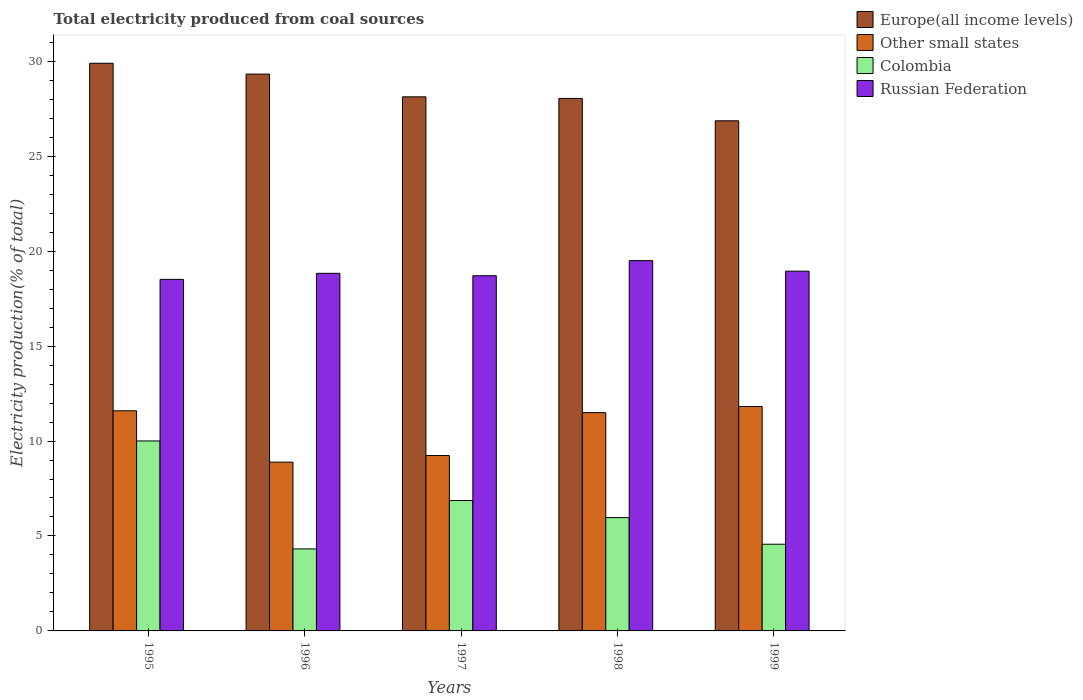Are the number of bars per tick equal to the number of legend labels?
Provide a succinct answer. Yes. Are the number of bars on each tick of the X-axis equal?
Your answer should be very brief. Yes. In how many cases, is the number of bars for a given year not equal to the number of legend labels?
Keep it short and to the point. 0. What is the total electricity produced in Europe(all income levels) in 1995?
Offer a very short reply. 29.89. Across all years, what is the maximum total electricity produced in Other small states?
Ensure brevity in your answer.  11.82. Across all years, what is the minimum total electricity produced in Colombia?
Offer a very short reply. 4.32. In which year was the total electricity produced in Russian Federation maximum?
Keep it short and to the point. 1998. What is the total total electricity produced in Colombia in the graph?
Your response must be concise. 31.72. What is the difference between the total electricity produced in Other small states in 1996 and that in 1998?
Your answer should be very brief. -2.61. What is the difference between the total electricity produced in Other small states in 1997 and the total electricity produced in Russian Federation in 1995?
Make the answer very short. -9.28. What is the average total electricity produced in Europe(all income levels) per year?
Keep it short and to the point. 28.45. In the year 1996, what is the difference between the total electricity produced in Colombia and total electricity produced in Russian Federation?
Give a very brief answer. -14.51. What is the ratio of the total electricity produced in Colombia in 1998 to that in 1999?
Your answer should be very brief. 1.31. Is the difference between the total electricity produced in Colombia in 1996 and 1999 greater than the difference between the total electricity produced in Russian Federation in 1996 and 1999?
Make the answer very short. No. What is the difference between the highest and the second highest total electricity produced in Colombia?
Ensure brevity in your answer.  3.14. What is the difference between the highest and the lowest total electricity produced in Other small states?
Your response must be concise. 2.93. Is the sum of the total electricity produced in Colombia in 1996 and 1998 greater than the maximum total electricity produced in Europe(all income levels) across all years?
Offer a terse response. No. What does the 1st bar from the right in 1996 represents?
Your response must be concise. Russian Federation. Is it the case that in every year, the sum of the total electricity produced in Europe(all income levels) and total electricity produced in Russian Federation is greater than the total electricity produced in Other small states?
Offer a terse response. Yes. How many bars are there?
Offer a very short reply. 20. How many years are there in the graph?
Offer a very short reply. 5. Are the values on the major ticks of Y-axis written in scientific E-notation?
Provide a short and direct response. No. Does the graph contain any zero values?
Ensure brevity in your answer.  No. How are the legend labels stacked?
Ensure brevity in your answer.  Vertical. What is the title of the graph?
Ensure brevity in your answer.  Total electricity produced from coal sources. Does "Bahrain" appear as one of the legend labels in the graph?
Give a very brief answer. No. What is the Electricity production(% of total) of Europe(all income levels) in 1995?
Provide a succinct answer. 29.89. What is the Electricity production(% of total) in Other small states in 1995?
Ensure brevity in your answer.  11.59. What is the Electricity production(% of total) in Colombia in 1995?
Keep it short and to the point. 10. What is the Electricity production(% of total) of Russian Federation in 1995?
Your response must be concise. 18.51. What is the Electricity production(% of total) in Europe(all income levels) in 1996?
Ensure brevity in your answer.  29.32. What is the Electricity production(% of total) of Other small states in 1996?
Give a very brief answer. 8.89. What is the Electricity production(% of total) of Colombia in 1996?
Your response must be concise. 4.32. What is the Electricity production(% of total) of Russian Federation in 1996?
Your answer should be very brief. 18.83. What is the Electricity production(% of total) in Europe(all income levels) in 1997?
Keep it short and to the point. 28.13. What is the Electricity production(% of total) in Other small states in 1997?
Ensure brevity in your answer.  9.24. What is the Electricity production(% of total) in Colombia in 1997?
Provide a short and direct response. 6.87. What is the Electricity production(% of total) in Russian Federation in 1997?
Your response must be concise. 18.7. What is the Electricity production(% of total) of Europe(all income levels) in 1998?
Keep it short and to the point. 28.04. What is the Electricity production(% of total) in Other small states in 1998?
Offer a terse response. 11.5. What is the Electricity production(% of total) in Colombia in 1998?
Make the answer very short. 5.97. What is the Electricity production(% of total) of Russian Federation in 1998?
Keep it short and to the point. 19.5. What is the Electricity production(% of total) in Europe(all income levels) in 1999?
Make the answer very short. 26.86. What is the Electricity production(% of total) of Other small states in 1999?
Offer a terse response. 11.82. What is the Electricity production(% of total) in Colombia in 1999?
Offer a very short reply. 4.57. What is the Electricity production(% of total) of Russian Federation in 1999?
Your answer should be compact. 18.94. Across all years, what is the maximum Electricity production(% of total) in Europe(all income levels)?
Ensure brevity in your answer.  29.89. Across all years, what is the maximum Electricity production(% of total) of Other small states?
Offer a terse response. 11.82. Across all years, what is the maximum Electricity production(% of total) in Colombia?
Make the answer very short. 10. Across all years, what is the maximum Electricity production(% of total) in Russian Federation?
Your answer should be very brief. 19.5. Across all years, what is the minimum Electricity production(% of total) of Europe(all income levels)?
Your response must be concise. 26.86. Across all years, what is the minimum Electricity production(% of total) in Other small states?
Provide a short and direct response. 8.89. Across all years, what is the minimum Electricity production(% of total) of Colombia?
Give a very brief answer. 4.32. Across all years, what is the minimum Electricity production(% of total) in Russian Federation?
Give a very brief answer. 18.51. What is the total Electricity production(% of total) of Europe(all income levels) in the graph?
Keep it short and to the point. 142.24. What is the total Electricity production(% of total) of Other small states in the graph?
Your answer should be very brief. 53.03. What is the total Electricity production(% of total) of Colombia in the graph?
Provide a short and direct response. 31.72. What is the total Electricity production(% of total) of Russian Federation in the graph?
Offer a very short reply. 94.49. What is the difference between the Electricity production(% of total) in Europe(all income levels) in 1995 and that in 1996?
Offer a very short reply. 0.57. What is the difference between the Electricity production(% of total) of Other small states in 1995 and that in 1996?
Your answer should be very brief. 2.7. What is the difference between the Electricity production(% of total) in Colombia in 1995 and that in 1996?
Your answer should be very brief. 5.68. What is the difference between the Electricity production(% of total) in Russian Federation in 1995 and that in 1996?
Provide a short and direct response. -0.32. What is the difference between the Electricity production(% of total) of Europe(all income levels) in 1995 and that in 1997?
Offer a terse response. 1.77. What is the difference between the Electricity production(% of total) of Other small states in 1995 and that in 1997?
Offer a very short reply. 2.36. What is the difference between the Electricity production(% of total) of Colombia in 1995 and that in 1997?
Your answer should be very brief. 3.14. What is the difference between the Electricity production(% of total) in Russian Federation in 1995 and that in 1997?
Provide a succinct answer. -0.19. What is the difference between the Electricity production(% of total) in Europe(all income levels) in 1995 and that in 1998?
Your answer should be very brief. 1.85. What is the difference between the Electricity production(% of total) of Other small states in 1995 and that in 1998?
Offer a very short reply. 0.1. What is the difference between the Electricity production(% of total) in Colombia in 1995 and that in 1998?
Provide a short and direct response. 4.04. What is the difference between the Electricity production(% of total) of Russian Federation in 1995 and that in 1998?
Offer a very short reply. -0.99. What is the difference between the Electricity production(% of total) of Europe(all income levels) in 1995 and that in 1999?
Offer a terse response. 3.03. What is the difference between the Electricity production(% of total) of Other small states in 1995 and that in 1999?
Your answer should be compact. -0.23. What is the difference between the Electricity production(% of total) of Colombia in 1995 and that in 1999?
Your answer should be very brief. 5.44. What is the difference between the Electricity production(% of total) in Russian Federation in 1995 and that in 1999?
Your answer should be compact. -0.43. What is the difference between the Electricity production(% of total) of Europe(all income levels) in 1996 and that in 1997?
Give a very brief answer. 1.2. What is the difference between the Electricity production(% of total) of Other small states in 1996 and that in 1997?
Offer a very short reply. -0.35. What is the difference between the Electricity production(% of total) of Colombia in 1996 and that in 1997?
Your response must be concise. -2.55. What is the difference between the Electricity production(% of total) of Russian Federation in 1996 and that in 1997?
Your answer should be very brief. 0.13. What is the difference between the Electricity production(% of total) in Europe(all income levels) in 1996 and that in 1998?
Offer a terse response. 1.28. What is the difference between the Electricity production(% of total) of Other small states in 1996 and that in 1998?
Your response must be concise. -2.61. What is the difference between the Electricity production(% of total) of Colombia in 1996 and that in 1998?
Give a very brief answer. -1.65. What is the difference between the Electricity production(% of total) of Russian Federation in 1996 and that in 1998?
Offer a terse response. -0.67. What is the difference between the Electricity production(% of total) in Europe(all income levels) in 1996 and that in 1999?
Your answer should be compact. 2.46. What is the difference between the Electricity production(% of total) of Other small states in 1996 and that in 1999?
Keep it short and to the point. -2.93. What is the difference between the Electricity production(% of total) in Colombia in 1996 and that in 1999?
Provide a short and direct response. -0.25. What is the difference between the Electricity production(% of total) of Russian Federation in 1996 and that in 1999?
Ensure brevity in your answer.  -0.11. What is the difference between the Electricity production(% of total) of Europe(all income levels) in 1997 and that in 1998?
Make the answer very short. 0.08. What is the difference between the Electricity production(% of total) of Other small states in 1997 and that in 1998?
Offer a terse response. -2.26. What is the difference between the Electricity production(% of total) of Colombia in 1997 and that in 1998?
Provide a short and direct response. 0.9. What is the difference between the Electricity production(% of total) in Russian Federation in 1997 and that in 1998?
Provide a succinct answer. -0.79. What is the difference between the Electricity production(% of total) of Europe(all income levels) in 1997 and that in 1999?
Make the answer very short. 1.26. What is the difference between the Electricity production(% of total) of Other small states in 1997 and that in 1999?
Keep it short and to the point. -2.58. What is the difference between the Electricity production(% of total) in Colombia in 1997 and that in 1999?
Offer a terse response. 2.3. What is the difference between the Electricity production(% of total) of Russian Federation in 1997 and that in 1999?
Keep it short and to the point. -0.24. What is the difference between the Electricity production(% of total) in Europe(all income levels) in 1998 and that in 1999?
Your response must be concise. 1.18. What is the difference between the Electricity production(% of total) in Other small states in 1998 and that in 1999?
Offer a terse response. -0.32. What is the difference between the Electricity production(% of total) in Colombia in 1998 and that in 1999?
Your answer should be very brief. 1.4. What is the difference between the Electricity production(% of total) in Russian Federation in 1998 and that in 1999?
Give a very brief answer. 0.55. What is the difference between the Electricity production(% of total) in Europe(all income levels) in 1995 and the Electricity production(% of total) in Other small states in 1996?
Provide a succinct answer. 21.01. What is the difference between the Electricity production(% of total) in Europe(all income levels) in 1995 and the Electricity production(% of total) in Colombia in 1996?
Ensure brevity in your answer.  25.57. What is the difference between the Electricity production(% of total) in Europe(all income levels) in 1995 and the Electricity production(% of total) in Russian Federation in 1996?
Your response must be concise. 11.06. What is the difference between the Electricity production(% of total) in Other small states in 1995 and the Electricity production(% of total) in Colombia in 1996?
Offer a very short reply. 7.27. What is the difference between the Electricity production(% of total) of Other small states in 1995 and the Electricity production(% of total) of Russian Federation in 1996?
Provide a succinct answer. -7.24. What is the difference between the Electricity production(% of total) in Colombia in 1995 and the Electricity production(% of total) in Russian Federation in 1996?
Ensure brevity in your answer.  -8.83. What is the difference between the Electricity production(% of total) in Europe(all income levels) in 1995 and the Electricity production(% of total) in Other small states in 1997?
Ensure brevity in your answer.  20.66. What is the difference between the Electricity production(% of total) of Europe(all income levels) in 1995 and the Electricity production(% of total) of Colombia in 1997?
Your answer should be very brief. 23.03. What is the difference between the Electricity production(% of total) in Europe(all income levels) in 1995 and the Electricity production(% of total) in Russian Federation in 1997?
Offer a terse response. 11.19. What is the difference between the Electricity production(% of total) of Other small states in 1995 and the Electricity production(% of total) of Colombia in 1997?
Your answer should be compact. 4.73. What is the difference between the Electricity production(% of total) in Other small states in 1995 and the Electricity production(% of total) in Russian Federation in 1997?
Offer a very short reply. -7.11. What is the difference between the Electricity production(% of total) of Colombia in 1995 and the Electricity production(% of total) of Russian Federation in 1997?
Offer a very short reply. -8.7. What is the difference between the Electricity production(% of total) in Europe(all income levels) in 1995 and the Electricity production(% of total) in Other small states in 1998?
Offer a terse response. 18.4. What is the difference between the Electricity production(% of total) in Europe(all income levels) in 1995 and the Electricity production(% of total) in Colombia in 1998?
Make the answer very short. 23.93. What is the difference between the Electricity production(% of total) of Europe(all income levels) in 1995 and the Electricity production(% of total) of Russian Federation in 1998?
Your response must be concise. 10.39. What is the difference between the Electricity production(% of total) in Other small states in 1995 and the Electricity production(% of total) in Colombia in 1998?
Your answer should be very brief. 5.63. What is the difference between the Electricity production(% of total) in Other small states in 1995 and the Electricity production(% of total) in Russian Federation in 1998?
Provide a succinct answer. -7.91. What is the difference between the Electricity production(% of total) in Colombia in 1995 and the Electricity production(% of total) in Russian Federation in 1998?
Give a very brief answer. -9.5. What is the difference between the Electricity production(% of total) in Europe(all income levels) in 1995 and the Electricity production(% of total) in Other small states in 1999?
Offer a terse response. 18.07. What is the difference between the Electricity production(% of total) in Europe(all income levels) in 1995 and the Electricity production(% of total) in Colombia in 1999?
Give a very brief answer. 25.33. What is the difference between the Electricity production(% of total) in Europe(all income levels) in 1995 and the Electricity production(% of total) in Russian Federation in 1999?
Your answer should be very brief. 10.95. What is the difference between the Electricity production(% of total) in Other small states in 1995 and the Electricity production(% of total) in Colombia in 1999?
Provide a short and direct response. 7.03. What is the difference between the Electricity production(% of total) in Other small states in 1995 and the Electricity production(% of total) in Russian Federation in 1999?
Provide a succinct answer. -7.35. What is the difference between the Electricity production(% of total) of Colombia in 1995 and the Electricity production(% of total) of Russian Federation in 1999?
Provide a short and direct response. -8.94. What is the difference between the Electricity production(% of total) of Europe(all income levels) in 1996 and the Electricity production(% of total) of Other small states in 1997?
Make the answer very short. 20.09. What is the difference between the Electricity production(% of total) of Europe(all income levels) in 1996 and the Electricity production(% of total) of Colombia in 1997?
Your answer should be compact. 22.45. What is the difference between the Electricity production(% of total) of Europe(all income levels) in 1996 and the Electricity production(% of total) of Russian Federation in 1997?
Offer a terse response. 10.62. What is the difference between the Electricity production(% of total) of Other small states in 1996 and the Electricity production(% of total) of Colombia in 1997?
Provide a succinct answer. 2.02. What is the difference between the Electricity production(% of total) in Other small states in 1996 and the Electricity production(% of total) in Russian Federation in 1997?
Provide a succinct answer. -9.82. What is the difference between the Electricity production(% of total) in Colombia in 1996 and the Electricity production(% of total) in Russian Federation in 1997?
Provide a succinct answer. -14.38. What is the difference between the Electricity production(% of total) in Europe(all income levels) in 1996 and the Electricity production(% of total) in Other small states in 1998?
Your response must be concise. 17.83. What is the difference between the Electricity production(% of total) of Europe(all income levels) in 1996 and the Electricity production(% of total) of Colombia in 1998?
Keep it short and to the point. 23.35. What is the difference between the Electricity production(% of total) of Europe(all income levels) in 1996 and the Electricity production(% of total) of Russian Federation in 1998?
Make the answer very short. 9.82. What is the difference between the Electricity production(% of total) of Other small states in 1996 and the Electricity production(% of total) of Colombia in 1998?
Keep it short and to the point. 2.92. What is the difference between the Electricity production(% of total) of Other small states in 1996 and the Electricity production(% of total) of Russian Federation in 1998?
Your answer should be very brief. -10.61. What is the difference between the Electricity production(% of total) in Colombia in 1996 and the Electricity production(% of total) in Russian Federation in 1998?
Provide a short and direct response. -15.18. What is the difference between the Electricity production(% of total) in Europe(all income levels) in 1996 and the Electricity production(% of total) in Other small states in 1999?
Your response must be concise. 17.5. What is the difference between the Electricity production(% of total) in Europe(all income levels) in 1996 and the Electricity production(% of total) in Colombia in 1999?
Ensure brevity in your answer.  24.76. What is the difference between the Electricity production(% of total) of Europe(all income levels) in 1996 and the Electricity production(% of total) of Russian Federation in 1999?
Offer a very short reply. 10.38. What is the difference between the Electricity production(% of total) of Other small states in 1996 and the Electricity production(% of total) of Colombia in 1999?
Your answer should be very brief. 4.32. What is the difference between the Electricity production(% of total) in Other small states in 1996 and the Electricity production(% of total) in Russian Federation in 1999?
Keep it short and to the point. -10.06. What is the difference between the Electricity production(% of total) of Colombia in 1996 and the Electricity production(% of total) of Russian Federation in 1999?
Make the answer very short. -14.63. What is the difference between the Electricity production(% of total) in Europe(all income levels) in 1997 and the Electricity production(% of total) in Other small states in 1998?
Keep it short and to the point. 16.63. What is the difference between the Electricity production(% of total) of Europe(all income levels) in 1997 and the Electricity production(% of total) of Colombia in 1998?
Ensure brevity in your answer.  22.16. What is the difference between the Electricity production(% of total) in Europe(all income levels) in 1997 and the Electricity production(% of total) in Russian Federation in 1998?
Your response must be concise. 8.63. What is the difference between the Electricity production(% of total) of Other small states in 1997 and the Electricity production(% of total) of Colombia in 1998?
Your response must be concise. 3.27. What is the difference between the Electricity production(% of total) of Other small states in 1997 and the Electricity production(% of total) of Russian Federation in 1998?
Your response must be concise. -10.26. What is the difference between the Electricity production(% of total) in Colombia in 1997 and the Electricity production(% of total) in Russian Federation in 1998?
Your answer should be compact. -12.63. What is the difference between the Electricity production(% of total) in Europe(all income levels) in 1997 and the Electricity production(% of total) in Other small states in 1999?
Provide a short and direct response. 16.31. What is the difference between the Electricity production(% of total) of Europe(all income levels) in 1997 and the Electricity production(% of total) of Colombia in 1999?
Offer a terse response. 23.56. What is the difference between the Electricity production(% of total) of Europe(all income levels) in 1997 and the Electricity production(% of total) of Russian Federation in 1999?
Offer a very short reply. 9.18. What is the difference between the Electricity production(% of total) in Other small states in 1997 and the Electricity production(% of total) in Colombia in 1999?
Your answer should be very brief. 4.67. What is the difference between the Electricity production(% of total) of Other small states in 1997 and the Electricity production(% of total) of Russian Federation in 1999?
Ensure brevity in your answer.  -9.71. What is the difference between the Electricity production(% of total) of Colombia in 1997 and the Electricity production(% of total) of Russian Federation in 1999?
Give a very brief answer. -12.08. What is the difference between the Electricity production(% of total) of Europe(all income levels) in 1998 and the Electricity production(% of total) of Other small states in 1999?
Your response must be concise. 16.22. What is the difference between the Electricity production(% of total) of Europe(all income levels) in 1998 and the Electricity production(% of total) of Colombia in 1999?
Keep it short and to the point. 23.48. What is the difference between the Electricity production(% of total) of Europe(all income levels) in 1998 and the Electricity production(% of total) of Russian Federation in 1999?
Your answer should be very brief. 9.1. What is the difference between the Electricity production(% of total) of Other small states in 1998 and the Electricity production(% of total) of Colombia in 1999?
Offer a very short reply. 6.93. What is the difference between the Electricity production(% of total) of Other small states in 1998 and the Electricity production(% of total) of Russian Federation in 1999?
Your answer should be very brief. -7.45. What is the difference between the Electricity production(% of total) of Colombia in 1998 and the Electricity production(% of total) of Russian Federation in 1999?
Keep it short and to the point. -12.98. What is the average Electricity production(% of total) in Europe(all income levels) per year?
Offer a very short reply. 28.45. What is the average Electricity production(% of total) of Other small states per year?
Your answer should be very brief. 10.61. What is the average Electricity production(% of total) in Colombia per year?
Provide a succinct answer. 6.34. What is the average Electricity production(% of total) in Russian Federation per year?
Provide a succinct answer. 18.9. In the year 1995, what is the difference between the Electricity production(% of total) of Europe(all income levels) and Electricity production(% of total) of Other small states?
Make the answer very short. 18.3. In the year 1995, what is the difference between the Electricity production(% of total) of Europe(all income levels) and Electricity production(% of total) of Colombia?
Keep it short and to the point. 19.89. In the year 1995, what is the difference between the Electricity production(% of total) of Europe(all income levels) and Electricity production(% of total) of Russian Federation?
Provide a succinct answer. 11.38. In the year 1995, what is the difference between the Electricity production(% of total) of Other small states and Electricity production(% of total) of Colombia?
Provide a succinct answer. 1.59. In the year 1995, what is the difference between the Electricity production(% of total) of Other small states and Electricity production(% of total) of Russian Federation?
Give a very brief answer. -6.92. In the year 1995, what is the difference between the Electricity production(% of total) in Colombia and Electricity production(% of total) in Russian Federation?
Ensure brevity in your answer.  -8.51. In the year 1996, what is the difference between the Electricity production(% of total) in Europe(all income levels) and Electricity production(% of total) in Other small states?
Your answer should be very brief. 20.43. In the year 1996, what is the difference between the Electricity production(% of total) in Europe(all income levels) and Electricity production(% of total) in Colombia?
Ensure brevity in your answer.  25. In the year 1996, what is the difference between the Electricity production(% of total) of Europe(all income levels) and Electricity production(% of total) of Russian Federation?
Offer a very short reply. 10.49. In the year 1996, what is the difference between the Electricity production(% of total) in Other small states and Electricity production(% of total) in Colombia?
Make the answer very short. 4.57. In the year 1996, what is the difference between the Electricity production(% of total) of Other small states and Electricity production(% of total) of Russian Federation?
Offer a terse response. -9.94. In the year 1996, what is the difference between the Electricity production(% of total) in Colombia and Electricity production(% of total) in Russian Federation?
Your answer should be very brief. -14.51. In the year 1997, what is the difference between the Electricity production(% of total) in Europe(all income levels) and Electricity production(% of total) in Other small states?
Keep it short and to the point. 18.89. In the year 1997, what is the difference between the Electricity production(% of total) of Europe(all income levels) and Electricity production(% of total) of Colombia?
Your answer should be compact. 21.26. In the year 1997, what is the difference between the Electricity production(% of total) of Europe(all income levels) and Electricity production(% of total) of Russian Federation?
Your answer should be compact. 9.42. In the year 1997, what is the difference between the Electricity production(% of total) in Other small states and Electricity production(% of total) in Colombia?
Make the answer very short. 2.37. In the year 1997, what is the difference between the Electricity production(% of total) in Other small states and Electricity production(% of total) in Russian Federation?
Ensure brevity in your answer.  -9.47. In the year 1997, what is the difference between the Electricity production(% of total) in Colombia and Electricity production(% of total) in Russian Federation?
Provide a succinct answer. -11.84. In the year 1998, what is the difference between the Electricity production(% of total) of Europe(all income levels) and Electricity production(% of total) of Other small states?
Give a very brief answer. 16.55. In the year 1998, what is the difference between the Electricity production(% of total) of Europe(all income levels) and Electricity production(% of total) of Colombia?
Provide a succinct answer. 22.07. In the year 1998, what is the difference between the Electricity production(% of total) of Europe(all income levels) and Electricity production(% of total) of Russian Federation?
Your answer should be very brief. 8.54. In the year 1998, what is the difference between the Electricity production(% of total) in Other small states and Electricity production(% of total) in Colombia?
Your answer should be very brief. 5.53. In the year 1998, what is the difference between the Electricity production(% of total) in Other small states and Electricity production(% of total) in Russian Federation?
Provide a succinct answer. -8. In the year 1998, what is the difference between the Electricity production(% of total) of Colombia and Electricity production(% of total) of Russian Federation?
Give a very brief answer. -13.53. In the year 1999, what is the difference between the Electricity production(% of total) of Europe(all income levels) and Electricity production(% of total) of Other small states?
Ensure brevity in your answer.  15.04. In the year 1999, what is the difference between the Electricity production(% of total) of Europe(all income levels) and Electricity production(% of total) of Colombia?
Give a very brief answer. 22.3. In the year 1999, what is the difference between the Electricity production(% of total) of Europe(all income levels) and Electricity production(% of total) of Russian Federation?
Offer a terse response. 7.92. In the year 1999, what is the difference between the Electricity production(% of total) of Other small states and Electricity production(% of total) of Colombia?
Keep it short and to the point. 7.25. In the year 1999, what is the difference between the Electricity production(% of total) in Other small states and Electricity production(% of total) in Russian Federation?
Your answer should be very brief. -7.13. In the year 1999, what is the difference between the Electricity production(% of total) of Colombia and Electricity production(% of total) of Russian Federation?
Your answer should be compact. -14.38. What is the ratio of the Electricity production(% of total) of Europe(all income levels) in 1995 to that in 1996?
Provide a short and direct response. 1.02. What is the ratio of the Electricity production(% of total) in Other small states in 1995 to that in 1996?
Ensure brevity in your answer.  1.3. What is the ratio of the Electricity production(% of total) of Colombia in 1995 to that in 1996?
Your answer should be very brief. 2.32. What is the ratio of the Electricity production(% of total) of Russian Federation in 1995 to that in 1996?
Give a very brief answer. 0.98. What is the ratio of the Electricity production(% of total) in Europe(all income levels) in 1995 to that in 1997?
Offer a very short reply. 1.06. What is the ratio of the Electricity production(% of total) in Other small states in 1995 to that in 1997?
Your answer should be compact. 1.26. What is the ratio of the Electricity production(% of total) in Colombia in 1995 to that in 1997?
Your answer should be compact. 1.46. What is the ratio of the Electricity production(% of total) of Europe(all income levels) in 1995 to that in 1998?
Your answer should be compact. 1.07. What is the ratio of the Electricity production(% of total) in Other small states in 1995 to that in 1998?
Offer a very short reply. 1.01. What is the ratio of the Electricity production(% of total) of Colombia in 1995 to that in 1998?
Make the answer very short. 1.68. What is the ratio of the Electricity production(% of total) of Russian Federation in 1995 to that in 1998?
Make the answer very short. 0.95. What is the ratio of the Electricity production(% of total) in Europe(all income levels) in 1995 to that in 1999?
Provide a short and direct response. 1.11. What is the ratio of the Electricity production(% of total) of Other small states in 1995 to that in 1999?
Keep it short and to the point. 0.98. What is the ratio of the Electricity production(% of total) of Colombia in 1995 to that in 1999?
Provide a short and direct response. 2.19. What is the ratio of the Electricity production(% of total) of Russian Federation in 1995 to that in 1999?
Give a very brief answer. 0.98. What is the ratio of the Electricity production(% of total) of Europe(all income levels) in 1996 to that in 1997?
Your answer should be compact. 1.04. What is the ratio of the Electricity production(% of total) in Other small states in 1996 to that in 1997?
Your response must be concise. 0.96. What is the ratio of the Electricity production(% of total) in Colombia in 1996 to that in 1997?
Give a very brief answer. 0.63. What is the ratio of the Electricity production(% of total) in Russian Federation in 1996 to that in 1997?
Offer a very short reply. 1.01. What is the ratio of the Electricity production(% of total) in Europe(all income levels) in 1996 to that in 1998?
Your response must be concise. 1.05. What is the ratio of the Electricity production(% of total) of Other small states in 1996 to that in 1998?
Offer a terse response. 0.77. What is the ratio of the Electricity production(% of total) in Colombia in 1996 to that in 1998?
Provide a succinct answer. 0.72. What is the ratio of the Electricity production(% of total) of Russian Federation in 1996 to that in 1998?
Your response must be concise. 0.97. What is the ratio of the Electricity production(% of total) in Europe(all income levels) in 1996 to that in 1999?
Your answer should be compact. 1.09. What is the ratio of the Electricity production(% of total) of Other small states in 1996 to that in 1999?
Keep it short and to the point. 0.75. What is the ratio of the Electricity production(% of total) in Colombia in 1996 to that in 1999?
Ensure brevity in your answer.  0.95. What is the ratio of the Electricity production(% of total) of Russian Federation in 1996 to that in 1999?
Your answer should be compact. 0.99. What is the ratio of the Electricity production(% of total) in Europe(all income levels) in 1997 to that in 1998?
Keep it short and to the point. 1. What is the ratio of the Electricity production(% of total) of Other small states in 1997 to that in 1998?
Provide a succinct answer. 0.8. What is the ratio of the Electricity production(% of total) of Colombia in 1997 to that in 1998?
Your response must be concise. 1.15. What is the ratio of the Electricity production(% of total) of Russian Federation in 1997 to that in 1998?
Keep it short and to the point. 0.96. What is the ratio of the Electricity production(% of total) in Europe(all income levels) in 1997 to that in 1999?
Your answer should be very brief. 1.05. What is the ratio of the Electricity production(% of total) in Other small states in 1997 to that in 1999?
Give a very brief answer. 0.78. What is the ratio of the Electricity production(% of total) of Colombia in 1997 to that in 1999?
Your response must be concise. 1.5. What is the ratio of the Electricity production(% of total) of Russian Federation in 1997 to that in 1999?
Your answer should be very brief. 0.99. What is the ratio of the Electricity production(% of total) of Europe(all income levels) in 1998 to that in 1999?
Your response must be concise. 1.04. What is the ratio of the Electricity production(% of total) in Other small states in 1998 to that in 1999?
Provide a short and direct response. 0.97. What is the ratio of the Electricity production(% of total) in Colombia in 1998 to that in 1999?
Your response must be concise. 1.31. What is the ratio of the Electricity production(% of total) of Russian Federation in 1998 to that in 1999?
Your answer should be very brief. 1.03. What is the difference between the highest and the second highest Electricity production(% of total) of Europe(all income levels)?
Ensure brevity in your answer.  0.57. What is the difference between the highest and the second highest Electricity production(% of total) in Other small states?
Give a very brief answer. 0.23. What is the difference between the highest and the second highest Electricity production(% of total) in Colombia?
Offer a terse response. 3.14. What is the difference between the highest and the second highest Electricity production(% of total) of Russian Federation?
Offer a terse response. 0.55. What is the difference between the highest and the lowest Electricity production(% of total) of Europe(all income levels)?
Provide a short and direct response. 3.03. What is the difference between the highest and the lowest Electricity production(% of total) in Other small states?
Provide a succinct answer. 2.93. What is the difference between the highest and the lowest Electricity production(% of total) of Colombia?
Offer a terse response. 5.68. What is the difference between the highest and the lowest Electricity production(% of total) in Russian Federation?
Keep it short and to the point. 0.99. 